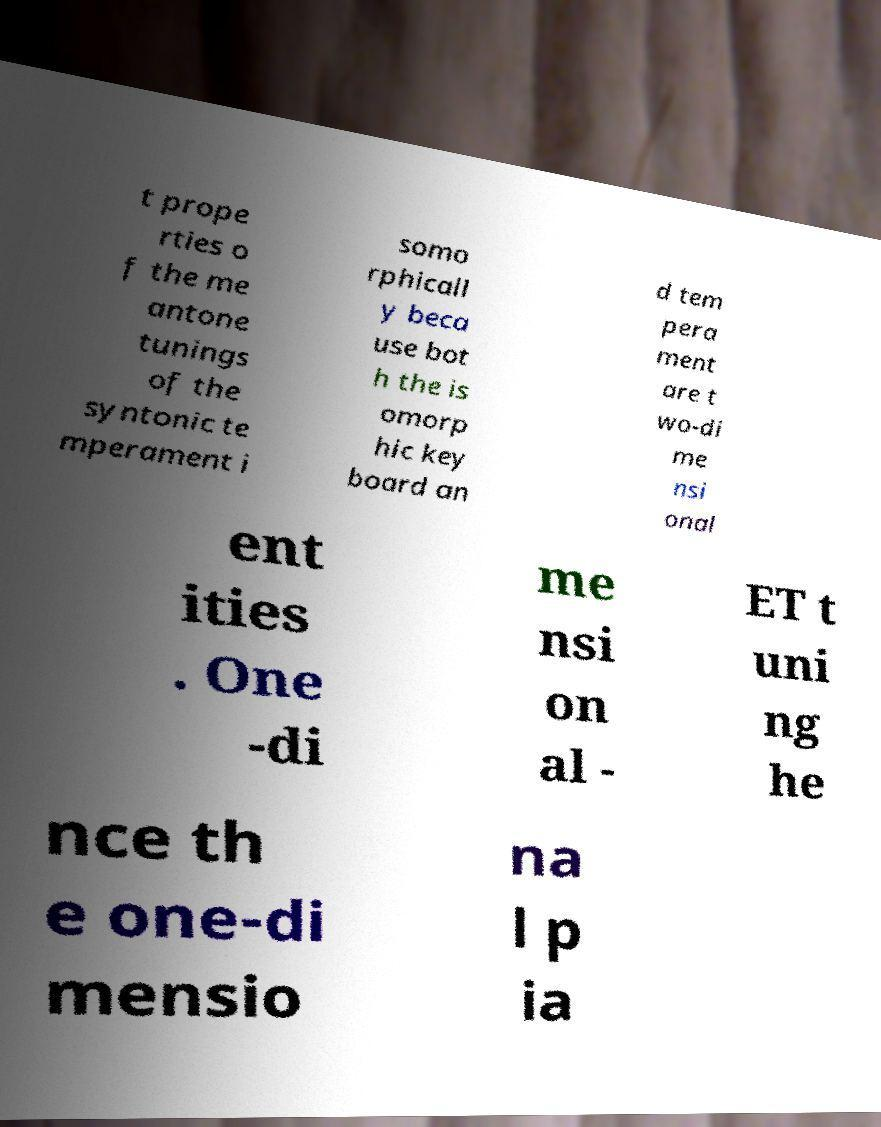Could you extract and type out the text from this image? t prope rties o f the me antone tunings of the syntonic te mperament i somo rphicall y beca use bot h the is omorp hic key board an d tem pera ment are t wo-di me nsi onal ent ities . One -di me nsi on al - ET t uni ng he nce th e one-di mensio na l p ia 